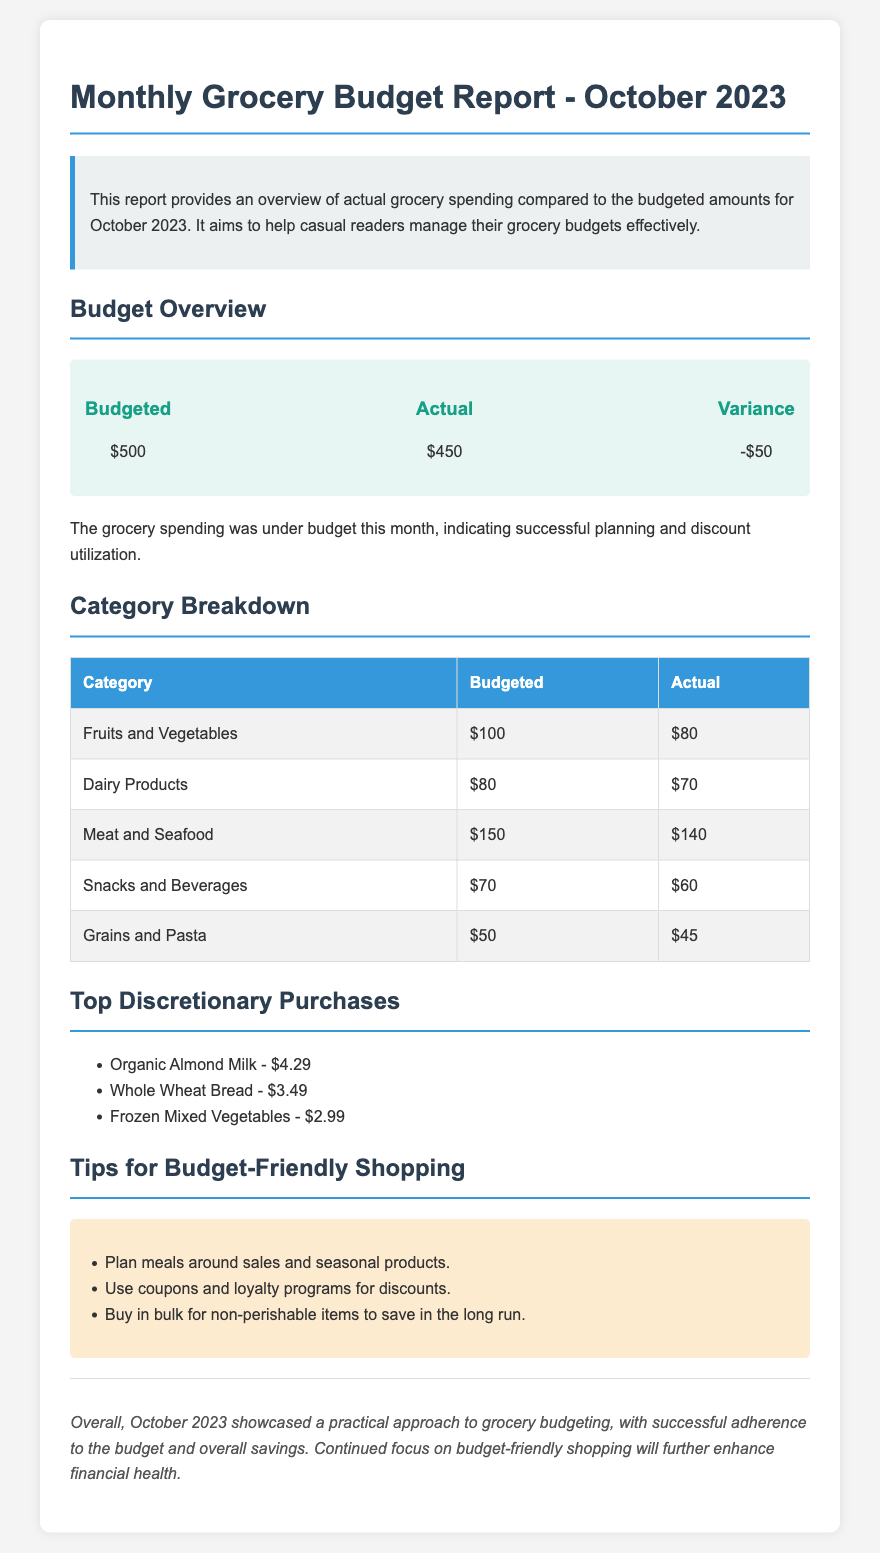What was the budgeted amount for grocery spending in October 2023? The budgeted amount is explicitly stated in the budget overview section of the document.
Answer: $500 What was the actual spending for groceries in October 2023? The actual spending is listed in the budget overview section and compared to the budgeted amount.
Answer: $450 What is the variance between the budgeted and actual spending? The variance is calculated by subtracting the actual spending from the budgeted amount, which is noted in the budget overview.
Answer: -$50 How much was spent on Fruits and Vegetables? The spending detail for each category, including Fruits and Vegetables, is provided in the category breakdown table.
Answer: $80 Which category had the highest budgeted amount? This information is gathered by comparing the budgeted amounts across all categories in the table.
Answer: Meat and Seafood What is one of the tips for budget-friendly shopping mentioned? Tips are listed in the tips section, focusing on practical shopping strategies.
Answer: Plan meals around sales and seasonal products What was the total of the top discretionary purchases? The total is calculated by adding the costs of all listed discretionary purchases.
Answer: $10.77 What conclusion is drawn about grocery budgeting for October 2023? The conclusion summarizes the overall approach and results of grocery budgeting this month.
Answer: Practical approach to grocery budgeting What is the main purpose of this report? The purpose is stated in the summary at the beginning of the document.
Answer: Help casual readers manage their grocery budgets effectively 